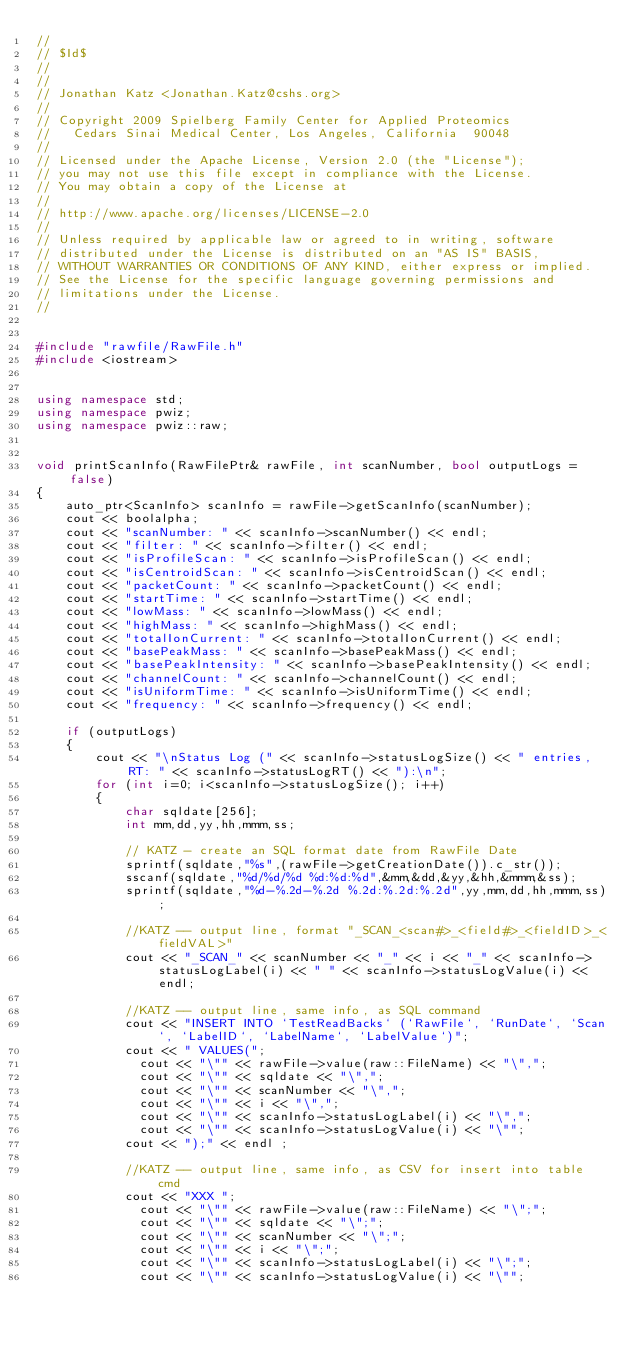Convert code to text. <code><loc_0><loc_0><loc_500><loc_500><_C++_>//
// $Id$
//
//
// Jonathan Katz <Jonathan.Katz@cshs.org>
//
// Copyright 2009 Spielberg Family Center for Applied Proteomics 
//   Cedars Sinai Medical Center, Los Angeles, California  90048
//
// Licensed under the Apache License, Version 2.0 (the "License"); 
// you may not use this file except in compliance with the License. 
// You may obtain a copy of the License at 
//
// http://www.apache.org/licenses/LICENSE-2.0
//
// Unless required by applicable law or agreed to in writing, software 
// distributed under the License is distributed on an "AS IS" BASIS, 
// WITHOUT WARRANTIES OR CONDITIONS OF ANY KIND, either express or implied. 
// See the License for the specific language governing permissions and 
// limitations under the License.
//


#include "rawfile/RawFile.h"
#include <iostream>


using namespace std;
using namespace pwiz;
using namespace pwiz::raw;


void printScanInfo(RawFilePtr& rawFile, int scanNumber, bool outputLogs = false)
{
    auto_ptr<ScanInfo> scanInfo = rawFile->getScanInfo(scanNumber);
    cout << boolalpha;
    cout << "scanNumber: " << scanInfo->scanNumber() << endl;
    cout << "filter: " << scanInfo->filter() << endl;
    cout << "isProfileScan: " << scanInfo->isProfileScan() << endl;
    cout << "isCentroidScan: " << scanInfo->isCentroidScan() << endl;
    cout << "packetCount: " << scanInfo->packetCount() << endl;
    cout << "startTime: " << scanInfo->startTime() << endl;
    cout << "lowMass: " << scanInfo->lowMass() << endl;
    cout << "highMass: " << scanInfo->highMass() << endl;
    cout << "totalIonCurrent: " << scanInfo->totalIonCurrent() << endl;
    cout << "basePeakMass: " << scanInfo->basePeakMass() << endl;
    cout << "basePeakIntensity: " << scanInfo->basePeakIntensity() << endl;
    cout << "channelCount: " << scanInfo->channelCount() << endl;
    cout << "isUniformTime: " << scanInfo->isUniformTime() << endl;
    cout << "frequency: " << scanInfo->frequency() << endl;
    
    if (outputLogs)
    {
        cout << "\nStatus Log (" << scanInfo->statusLogSize() << " entries, RT: " << scanInfo->statusLogRT() << "):\n";
        for (int i=0; i<scanInfo->statusLogSize(); i++)
		{
			char sqldate[256];
	        int mm,dd,yy,hh,mmm,ss;

			// KATZ - create an SQL format date from RawFile Date
			sprintf(sqldate,"%s",(rawFile->getCreationDate()).c_str());            
			sscanf(sqldate,"%d/%d/%d %d:%d:%d",&mm,&dd,&yy,&hh,&mmm,&ss);
			sprintf(sqldate,"%d-%.2d-%.2d %.2d:%.2d:%.2d",yy,mm,dd,hh,mmm,ss);

			//KATZ -- output line, format "_SCAN_<scan#>_<field#>_<fieldID>_<fieldVAL>"
			cout << "_SCAN_" << scanNumber << "_" << i << "_" << scanInfo->statusLogLabel(i) << " " << scanInfo->statusLogValue(i) << endl;
            
			//KATZ -- output line, same info, as SQL command
			cout << "INSERT INTO `TestReadBacks` (`RawFile`, `RunDate`, `Scan`, `LabelID`, `LabelName`, `LabelValue`)";
			cout << " VALUES(";
              cout << "\"" << rawFile->value(raw::FileName) << "\",";
			  cout << "\"" << sqldate << "\",";
              cout << "\"" << scanNumber << "\",";
			  cout << "\"" << i << "\",";
              cout << "\"" << scanInfo->statusLogLabel(i) << "\",";
              cout << "\"" << scanInfo->statusLogValue(i) << "\"";
			cout << ");" << endl ;

			//KATZ -- output line, same info, as CSV for insert into table cmd
            cout << "XXX ";
              cout << "\"" << rawFile->value(raw::FileName) << "\";";
			  cout << "\"" << sqldate << "\";";
              cout << "\"" << scanNumber << "\";";
			  cout << "\"" << i << "\";";
              cout << "\"" << scanInfo->statusLogLabel(i) << "\";";
              cout << "\"" << scanInfo->statusLogValue(i) << "\"";</code> 